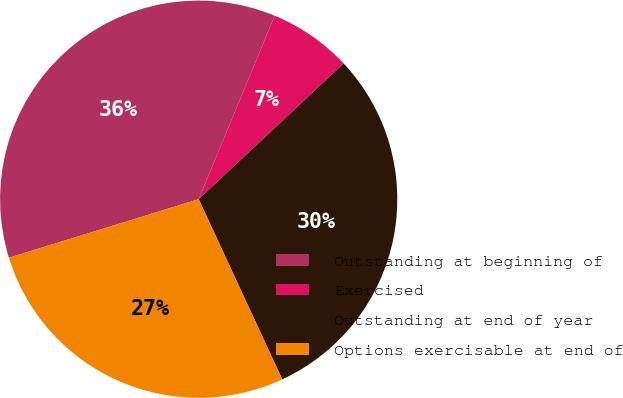<chart> <loc_0><loc_0><loc_500><loc_500><pie_chart><fcel>Outstanding at beginning of<fcel>Exercised<fcel>Outstanding at end of year<fcel>Options exercisable at end of<nl><fcel>36.01%<fcel>6.77%<fcel>30.07%<fcel>27.15%<nl></chart> 